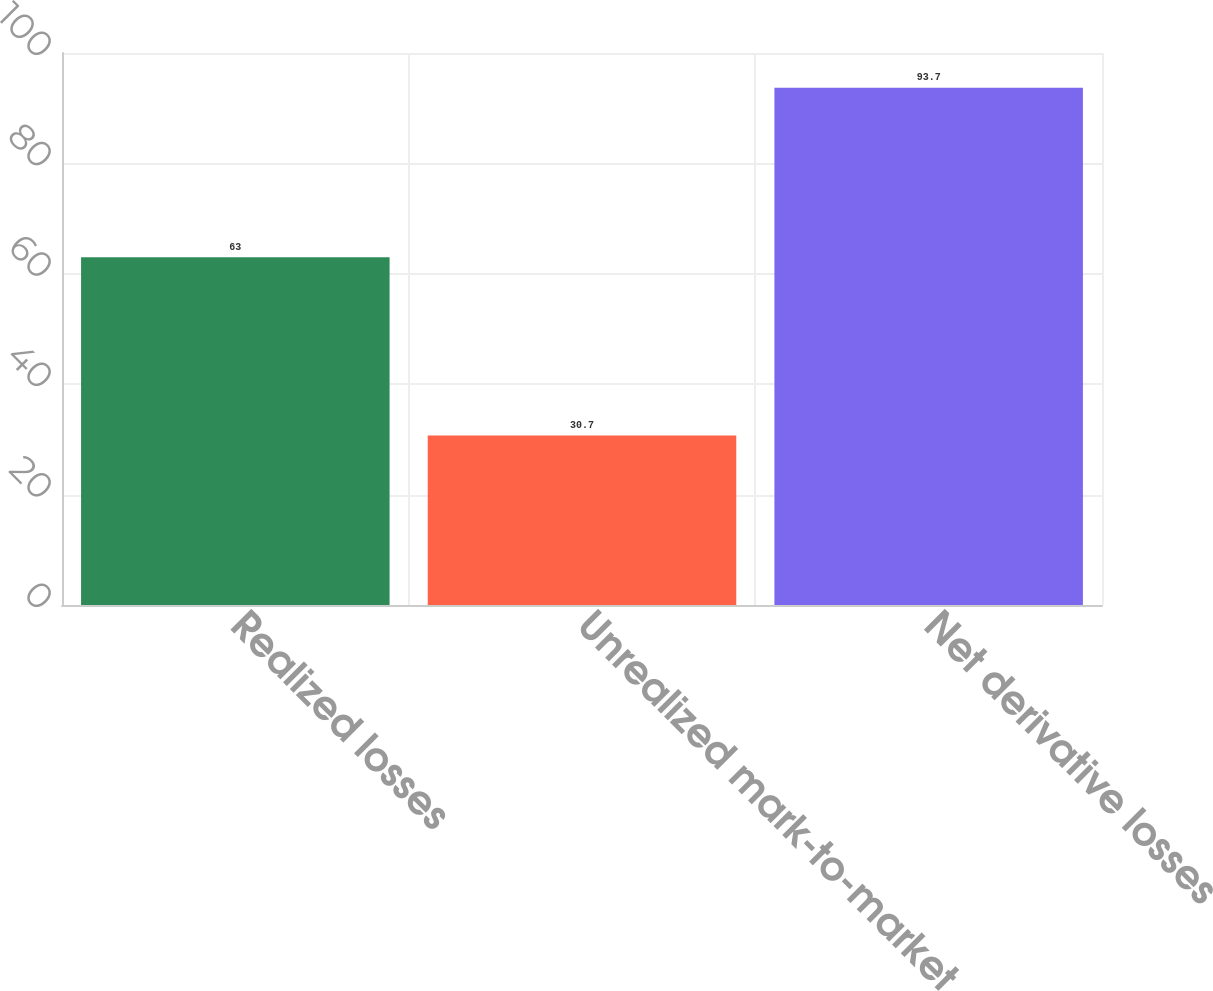<chart> <loc_0><loc_0><loc_500><loc_500><bar_chart><fcel>Realized losses<fcel>Unrealized mark-to-market<fcel>Net derivative losses<nl><fcel>63<fcel>30.7<fcel>93.7<nl></chart> 